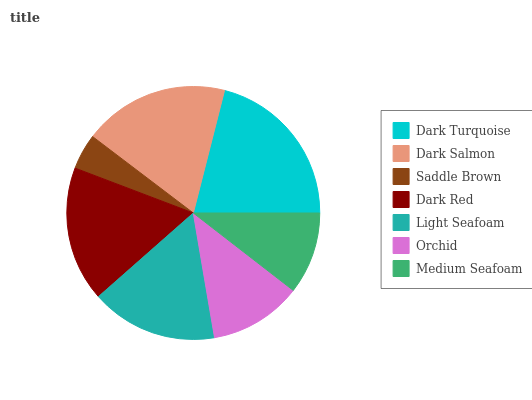Is Saddle Brown the minimum?
Answer yes or no. Yes. Is Dark Turquoise the maximum?
Answer yes or no. Yes. Is Dark Salmon the minimum?
Answer yes or no. No. Is Dark Salmon the maximum?
Answer yes or no. No. Is Dark Turquoise greater than Dark Salmon?
Answer yes or no. Yes. Is Dark Salmon less than Dark Turquoise?
Answer yes or no. Yes. Is Dark Salmon greater than Dark Turquoise?
Answer yes or no. No. Is Dark Turquoise less than Dark Salmon?
Answer yes or no. No. Is Light Seafoam the high median?
Answer yes or no. Yes. Is Light Seafoam the low median?
Answer yes or no. Yes. Is Dark Salmon the high median?
Answer yes or no. No. Is Dark Salmon the low median?
Answer yes or no. No. 